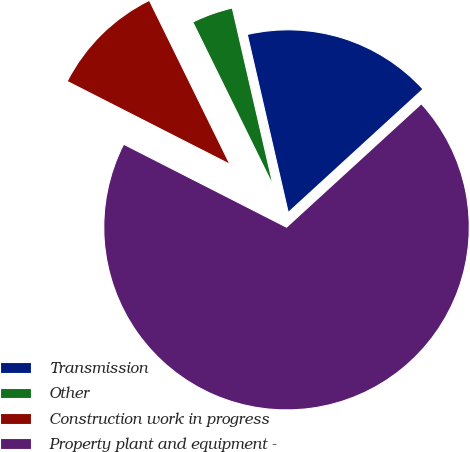Convert chart to OTSL. <chart><loc_0><loc_0><loc_500><loc_500><pie_chart><fcel>Transmission<fcel>Other<fcel>Construction work in progress<fcel>Property plant and equipment -<nl><fcel>16.8%<fcel>3.67%<fcel>10.23%<fcel>69.3%<nl></chart> 